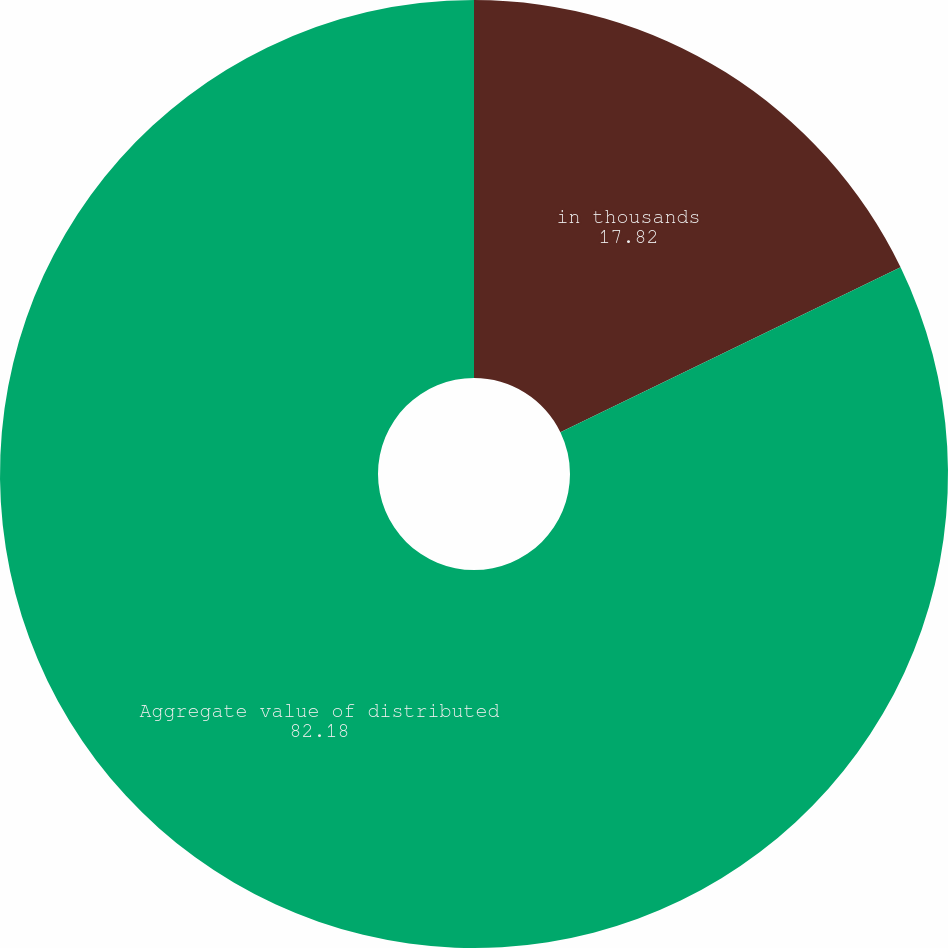<chart> <loc_0><loc_0><loc_500><loc_500><pie_chart><fcel>in thousands<fcel>Aggregate value of distributed<nl><fcel>17.82%<fcel>82.18%<nl></chart> 